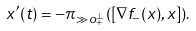Convert formula to latex. <formula><loc_0><loc_0><loc_500><loc_500>x ^ { \prime } ( t ) = - \pi _ { \gg o _ { + } ^ { \perp } } ( [ \nabla f _ { - } ( x ) , x ] ) .</formula> 